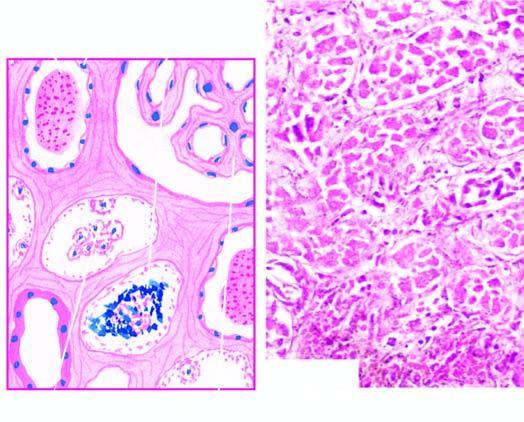s the cytoplasm extensive necrosis of epithelial cells involving predominantly proximal convoluted tubule diffusely?
Answer the question using a single word or phrase. No 